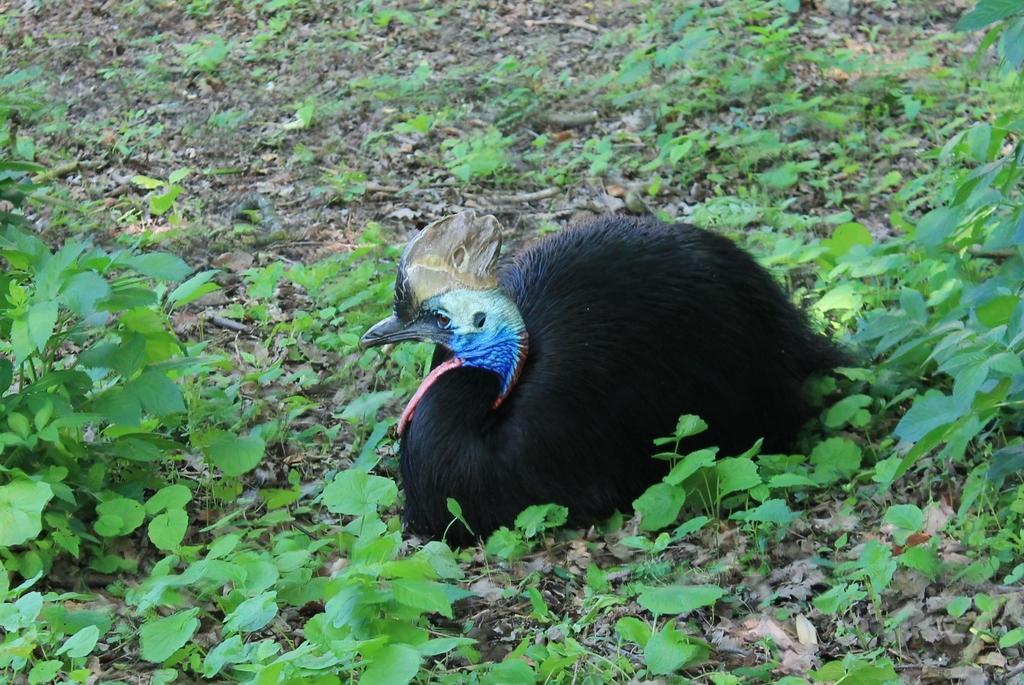Describe this image in one or two sentences. In this image there are plantś, there is a bird sitting on the ground. 